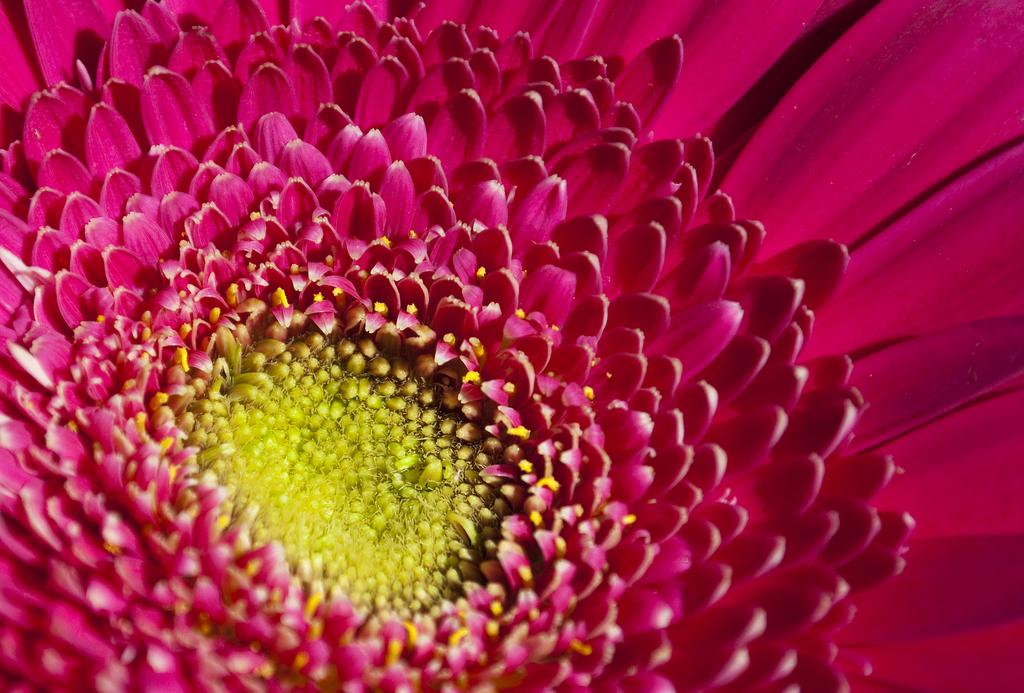What type of living organism can be seen in the image? There is a flower in the image. What type of band is playing in the background of the image? There is no band present in the image; it only features a flower. 